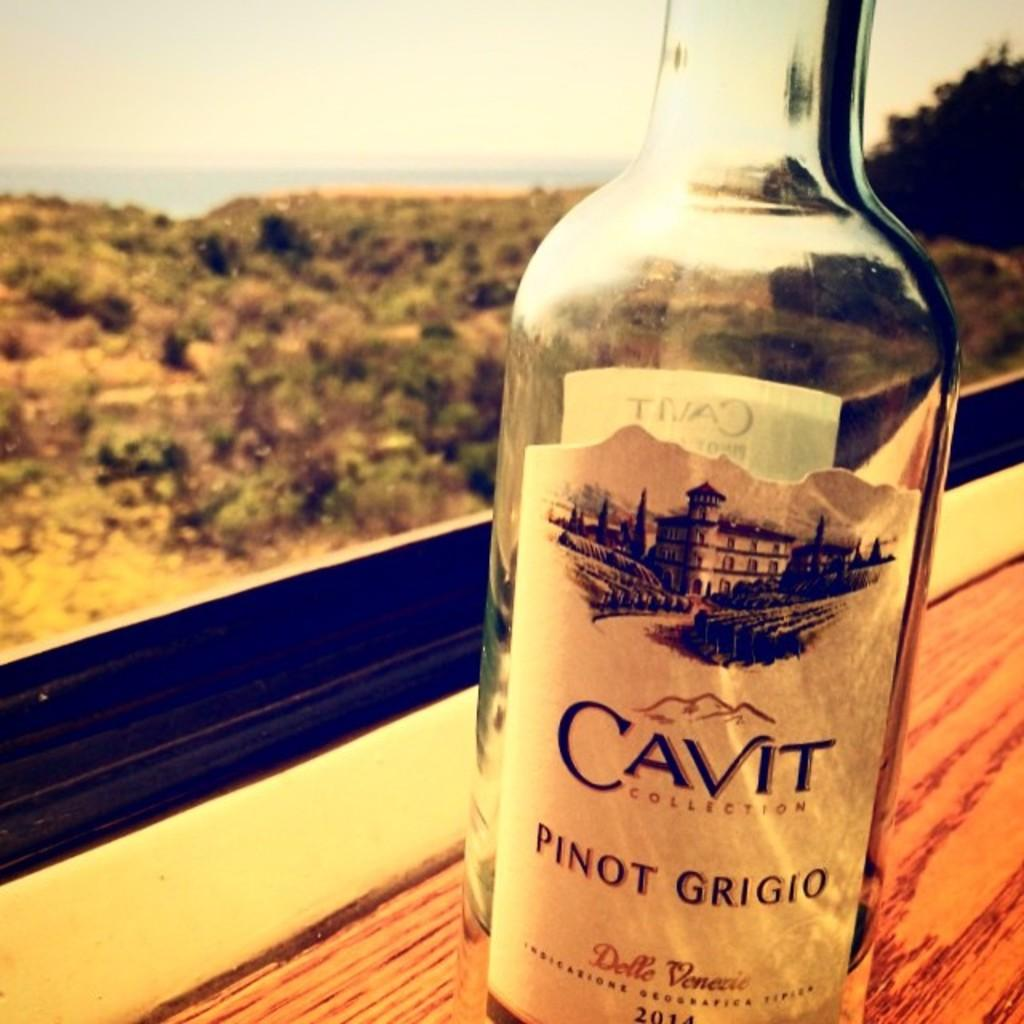What object can be seen in the image? There is a glass bottle in the image. What can be seen in the distance in the image? Trees are visible in the background of the image. What is written on the label of the glass bottle? The label on the glass bottle has "cavit collection" written on it. Is there any rain visible in the image? There is no rain visible in the image. How does the light affect the visibility of the glass bottle in the image? The image does not provide information about the lighting conditions, so it is impossible to determine how the light affects the visibility of the glass bottle. 